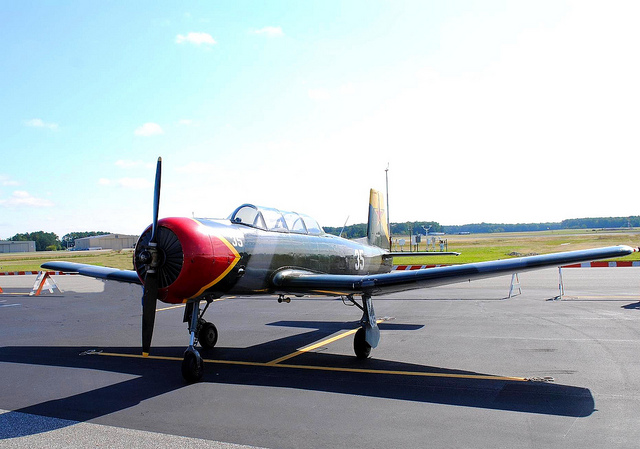Identify and read out the text in this image. 35 35 